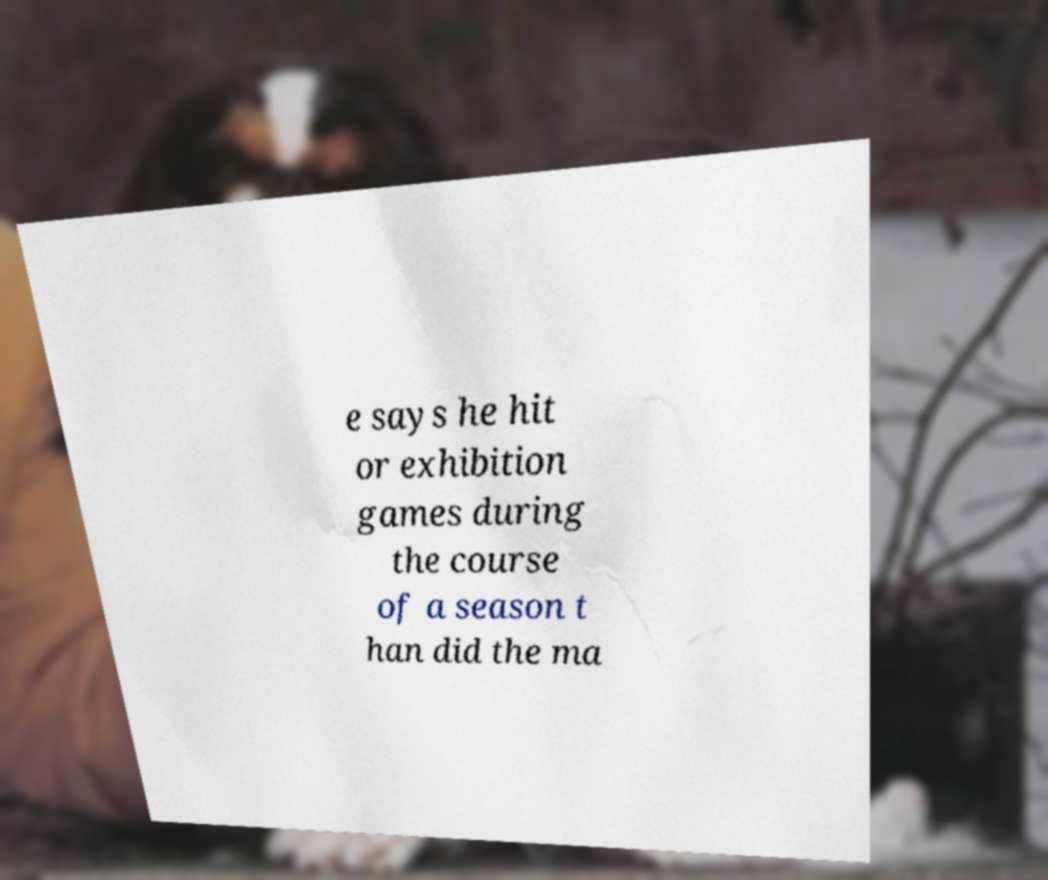What messages or text are displayed in this image? I need them in a readable, typed format. e says he hit or exhibition games during the course of a season t han did the ma 